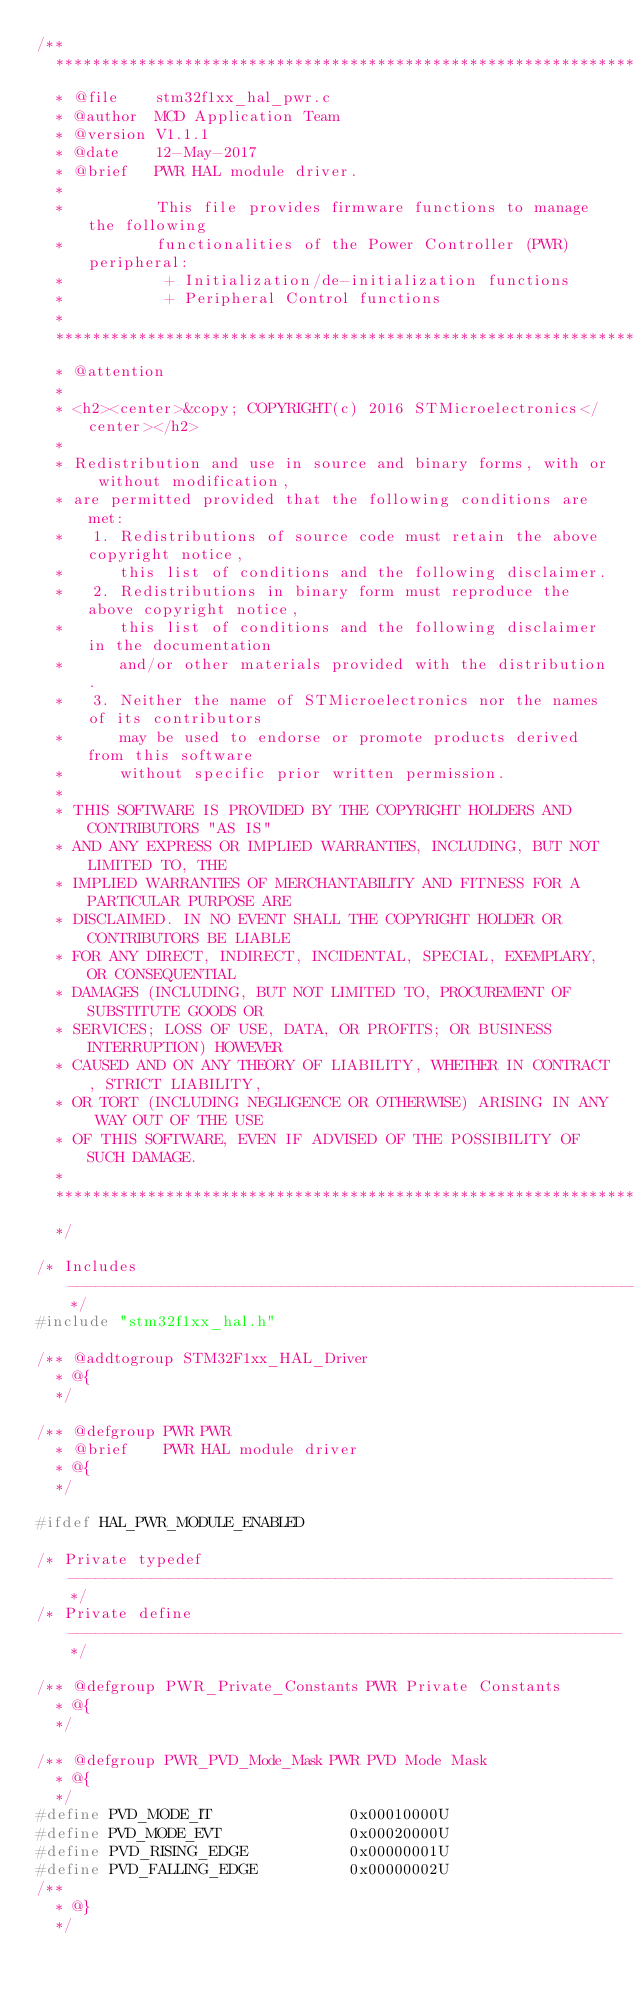Convert code to text. <code><loc_0><loc_0><loc_500><loc_500><_C_>/**
  ******************************************************************************
  * @file    stm32f1xx_hal_pwr.c
  * @author  MCD Application Team
  * @version V1.1.1
  * @date    12-May-2017
  * @brief   PWR HAL module driver.
  *
  *          This file provides firmware functions to manage the following
  *          functionalities of the Power Controller (PWR) peripheral:
  *           + Initialization/de-initialization functions
  *           + Peripheral Control functions
  *
  ******************************************************************************
  * @attention
  *
  * <h2><center>&copy; COPYRIGHT(c) 2016 STMicroelectronics</center></h2>
  *
  * Redistribution and use in source and binary forms, with or without modification,
  * are permitted provided that the following conditions are met:
  *   1. Redistributions of source code must retain the above copyright notice,
  *      this list of conditions and the following disclaimer.
  *   2. Redistributions in binary form must reproduce the above copyright notice,
  *      this list of conditions and the following disclaimer in the documentation
  *      and/or other materials provided with the distribution.
  *   3. Neither the name of STMicroelectronics nor the names of its contributors
  *      may be used to endorse or promote products derived from this software
  *      without specific prior written permission.
  *
  * THIS SOFTWARE IS PROVIDED BY THE COPYRIGHT HOLDERS AND CONTRIBUTORS "AS IS"
  * AND ANY EXPRESS OR IMPLIED WARRANTIES, INCLUDING, BUT NOT LIMITED TO, THE
  * IMPLIED WARRANTIES OF MERCHANTABILITY AND FITNESS FOR A PARTICULAR PURPOSE ARE
  * DISCLAIMED. IN NO EVENT SHALL THE COPYRIGHT HOLDER OR CONTRIBUTORS BE LIABLE
  * FOR ANY DIRECT, INDIRECT, INCIDENTAL, SPECIAL, EXEMPLARY, OR CONSEQUENTIAL
  * DAMAGES (INCLUDING, BUT NOT LIMITED TO, PROCUREMENT OF SUBSTITUTE GOODS OR
  * SERVICES; LOSS OF USE, DATA, OR PROFITS; OR BUSINESS INTERRUPTION) HOWEVER
  * CAUSED AND ON ANY THEORY OF LIABILITY, WHETHER IN CONTRACT, STRICT LIABILITY,
  * OR TORT (INCLUDING NEGLIGENCE OR OTHERWISE) ARISING IN ANY WAY OUT OF THE USE
  * OF THIS SOFTWARE, EVEN IF ADVISED OF THE POSSIBILITY OF SUCH DAMAGE.
  *
  ******************************************************************************
  */

/* Includes ------------------------------------------------------------------*/
#include "stm32f1xx_hal.h"

/** @addtogroup STM32F1xx_HAL_Driver
  * @{
  */

/** @defgroup PWR PWR
  * @brief    PWR HAL module driver
  * @{
  */

#ifdef HAL_PWR_MODULE_ENABLED

/* Private typedef -----------------------------------------------------------*/
/* Private define ------------------------------------------------------------*/

/** @defgroup PWR_Private_Constants PWR Private Constants
  * @{
  */

/** @defgroup PWR_PVD_Mode_Mask PWR PVD Mode Mask
  * @{
  */
#define PVD_MODE_IT               0x00010000U
#define PVD_MODE_EVT              0x00020000U
#define PVD_RISING_EDGE           0x00000001U
#define PVD_FALLING_EDGE          0x00000002U
/**
  * @}
  */

</code> 